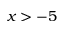<formula> <loc_0><loc_0><loc_500><loc_500>x > - 5</formula> 